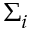Convert formula to latex. <formula><loc_0><loc_0><loc_500><loc_500>\Sigma _ { i }</formula> 